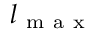<formula> <loc_0><loc_0><loc_500><loc_500>l _ { m a x }</formula> 